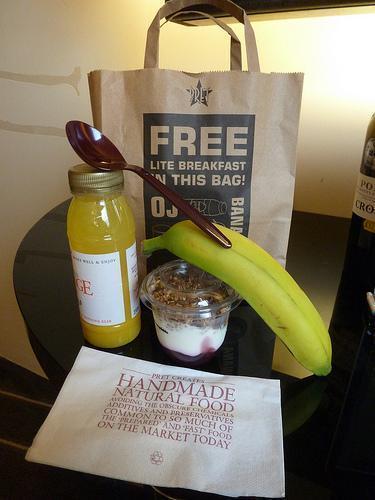How many items came out of the bag?
Give a very brief answer. 5. 